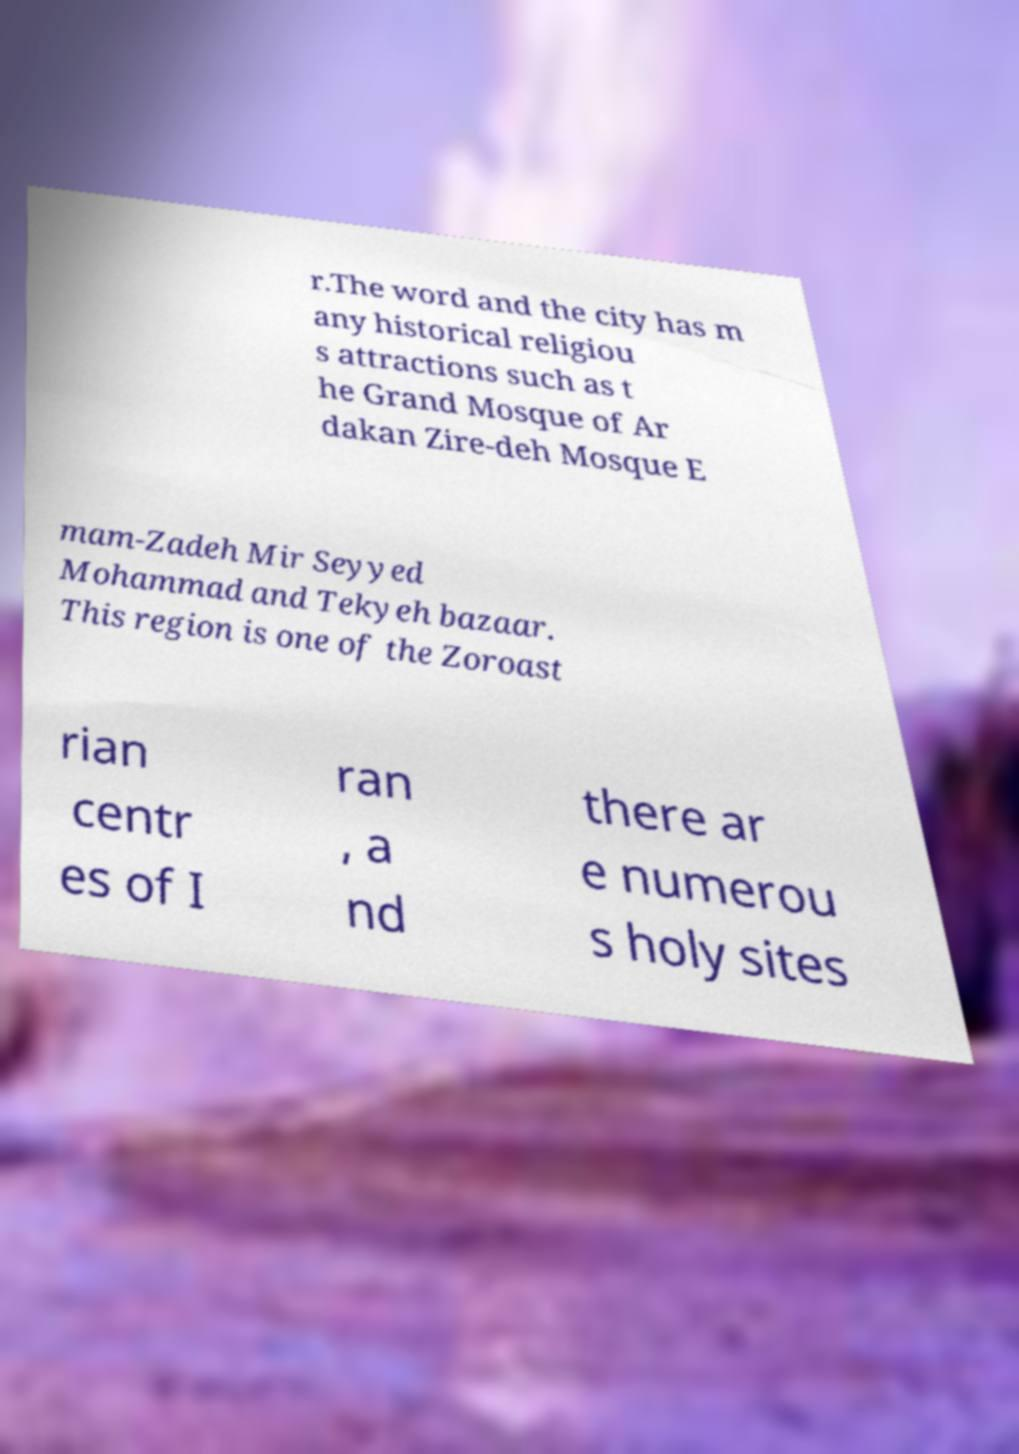Can you accurately transcribe the text from the provided image for me? r.The word and the city has m any historical religiou s attractions such as t he Grand Mosque of Ar dakan Zire-deh Mosque E mam-Zadeh Mir Seyyed Mohammad and Tekyeh bazaar. This region is one of the Zoroast rian centr es of I ran , a nd there ar e numerou s holy sites 